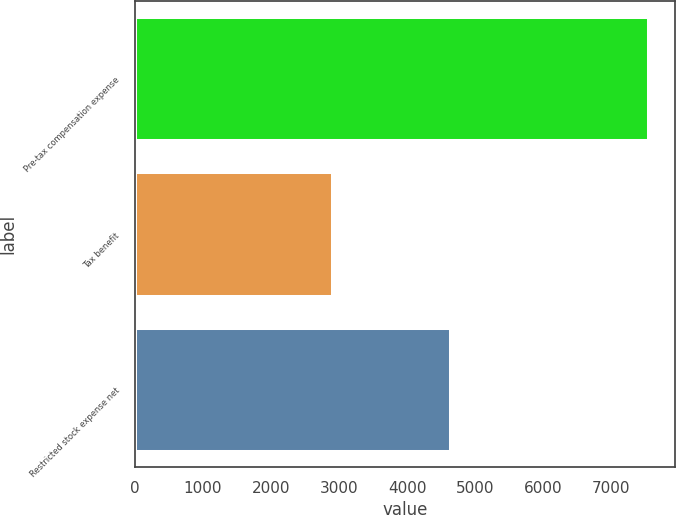<chart> <loc_0><loc_0><loc_500><loc_500><bar_chart><fcel>Pre-tax compensation expense<fcel>Tax benefit<fcel>Restricted stock expense net<nl><fcel>7555<fcel>2909<fcel>4646<nl></chart> 